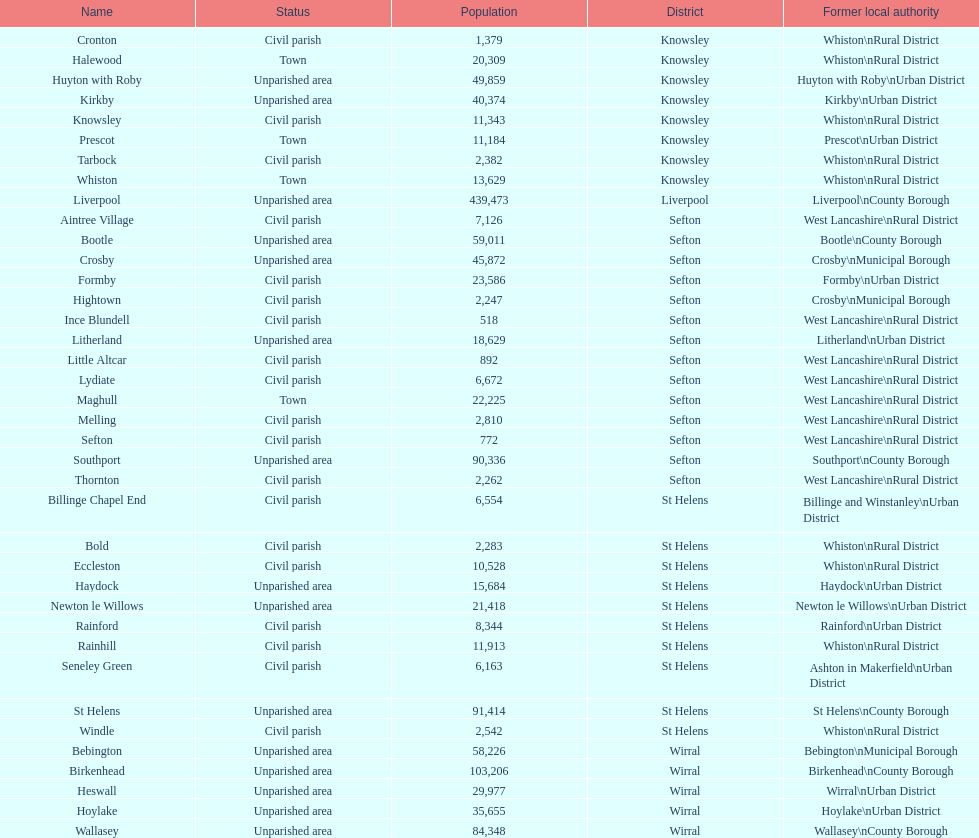Would you be able to parse every entry in this table? {'header': ['Name', 'Status', 'Population', 'District', 'Former local authority'], 'rows': [['Cronton', 'Civil parish', '1,379', 'Knowsley', 'Whiston\\nRural District'], ['Halewood', 'Town', '20,309', 'Knowsley', 'Whiston\\nRural District'], ['Huyton with Roby', 'Unparished area', '49,859', 'Knowsley', 'Huyton with Roby\\nUrban District'], ['Kirkby', 'Unparished area', '40,374', 'Knowsley', 'Kirkby\\nUrban District'], ['Knowsley', 'Civil parish', '11,343', 'Knowsley', 'Whiston\\nRural District'], ['Prescot', 'Town', '11,184', 'Knowsley', 'Prescot\\nUrban District'], ['Tarbock', 'Civil parish', '2,382', 'Knowsley', 'Whiston\\nRural District'], ['Whiston', 'Town', '13,629', 'Knowsley', 'Whiston\\nRural District'], ['Liverpool', 'Unparished area', '439,473', 'Liverpool', 'Liverpool\\nCounty Borough'], ['Aintree Village', 'Civil parish', '7,126', 'Sefton', 'West Lancashire\\nRural District'], ['Bootle', 'Unparished area', '59,011', 'Sefton', 'Bootle\\nCounty Borough'], ['Crosby', 'Unparished area', '45,872', 'Sefton', 'Crosby\\nMunicipal Borough'], ['Formby', 'Civil parish', '23,586', 'Sefton', 'Formby\\nUrban District'], ['Hightown', 'Civil parish', '2,247', 'Sefton', 'Crosby\\nMunicipal Borough'], ['Ince Blundell', 'Civil parish', '518', 'Sefton', 'West Lancashire\\nRural District'], ['Litherland', 'Unparished area', '18,629', 'Sefton', 'Litherland\\nUrban District'], ['Little Altcar', 'Civil parish', '892', 'Sefton', 'West Lancashire\\nRural District'], ['Lydiate', 'Civil parish', '6,672', 'Sefton', 'West Lancashire\\nRural District'], ['Maghull', 'Town', '22,225', 'Sefton', 'West Lancashire\\nRural District'], ['Melling', 'Civil parish', '2,810', 'Sefton', 'West Lancashire\\nRural District'], ['Sefton', 'Civil parish', '772', 'Sefton', 'West Lancashire\\nRural District'], ['Southport', 'Unparished area', '90,336', 'Sefton', 'Southport\\nCounty Borough'], ['Thornton', 'Civil parish', '2,262', 'Sefton', 'West Lancashire\\nRural District'], ['Billinge Chapel End', 'Civil parish', '6,554', 'St Helens', 'Billinge and Winstanley\\nUrban District'], ['Bold', 'Civil parish', '2,283', 'St Helens', 'Whiston\\nRural District'], ['Eccleston', 'Civil parish', '10,528', 'St Helens', 'Whiston\\nRural District'], ['Haydock', 'Unparished area', '15,684', 'St Helens', 'Haydock\\nUrban District'], ['Newton le Willows', 'Unparished area', '21,418', 'St Helens', 'Newton le Willows\\nUrban District'], ['Rainford', 'Civil parish', '8,344', 'St Helens', 'Rainford\\nUrban District'], ['Rainhill', 'Civil parish', '11,913', 'St Helens', 'Whiston\\nRural District'], ['Seneley Green', 'Civil parish', '6,163', 'St Helens', 'Ashton in Makerfield\\nUrban District'], ['St Helens', 'Unparished area', '91,414', 'St Helens', 'St Helens\\nCounty Borough'], ['Windle', 'Civil parish', '2,542', 'St Helens', 'Whiston\\nRural District'], ['Bebington', 'Unparished area', '58,226', 'Wirral', 'Bebington\\nMunicipal Borough'], ['Birkenhead', 'Unparished area', '103,206', 'Wirral', 'Birkenhead\\nCounty Borough'], ['Heswall', 'Unparished area', '29,977', 'Wirral', 'Wirral\\nUrban District'], ['Hoylake', 'Unparished area', '35,655', 'Wirral', 'Hoylake\\nUrban District'], ['Wallasey', 'Unparished area', '84,348', 'Wirral', 'Wallasey\\nCounty Borough']]} Tell me the number of residents in formby. 23,586. 